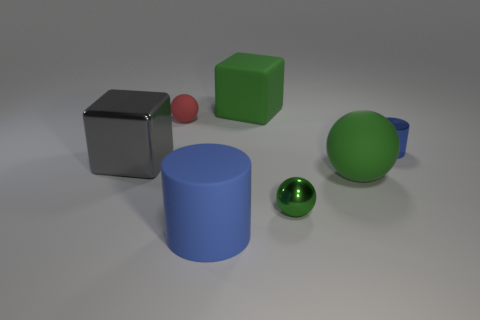There is a big green thing that is in front of the tiny blue metallic thing; is there a green sphere that is right of it?
Provide a short and direct response. No. What number of things are either large cubes in front of the red thing or small objects that are in front of the small blue metal object?
Keep it short and to the point. 2. Is there any other thing that is the same color as the shiny ball?
Offer a very short reply. Yes. What is the color of the metal object that is to the left of the blue object on the left side of the matte sphere that is in front of the small shiny cylinder?
Your response must be concise. Gray. There is a green matte object in front of the block that is on the right side of the large blue rubber cylinder; how big is it?
Give a very brief answer. Large. The small object that is behind the small metallic ball and right of the rubber block is made of what material?
Offer a terse response. Metal. There is a green metallic sphere; does it have the same size as the blue thing in front of the tiny cylinder?
Your answer should be very brief. No. Are there any green blocks?
Provide a short and direct response. Yes. There is another thing that is the same shape as the gray shiny object; what is it made of?
Your response must be concise. Rubber. There is a red sphere that is left of the small blue metal thing that is on the right side of the big green object in front of the shiny cylinder; how big is it?
Your response must be concise. Small. 